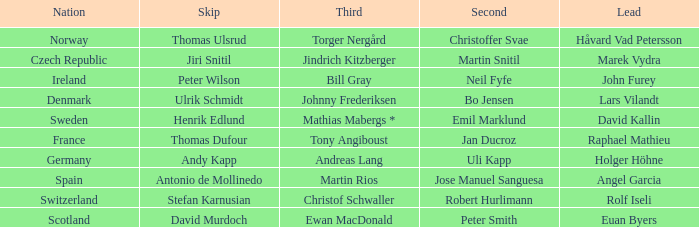When did France come in second? Jan Ducroz. 